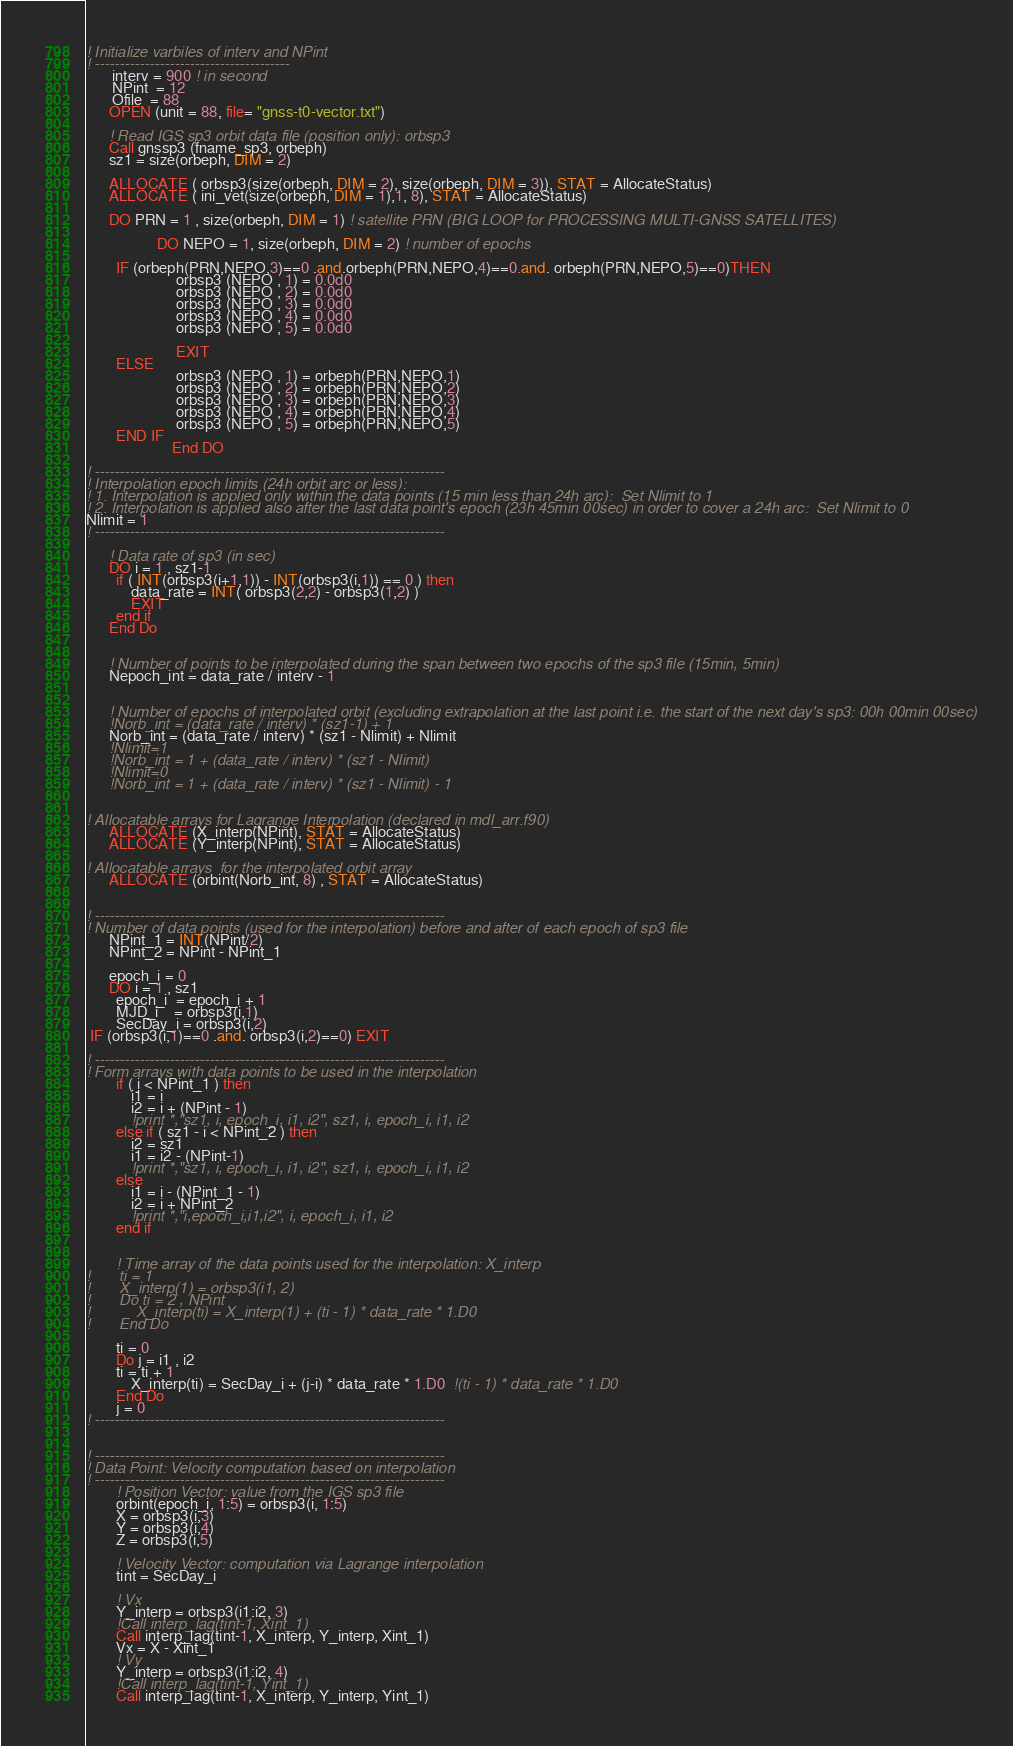Convert code to text. <code><loc_0><loc_0><loc_500><loc_500><_FORTRAN_>! Initialize varbiles of interv and NPint
! ---------------------------------------
       interv = 900 ! in second
       NPint  = 12 
       Ofile  = 88
      OPEN (unit = 88, file= "gnss-t0-vector.txt")

	  ! Read IGS sp3 orbit data file (position only): orbsp3 
      Call gnssp3 (fname_sp3, orbeph)
	  sz1 = size(orbeph, DIM = 2)

      ALLOCATE ( orbsp3(size(orbeph, DIM = 2), size(orbeph, DIM = 3)), STAT = AllocateStatus)
      ALLOCATE ( ini_vet(size(orbeph, DIM = 1),1, 8), STAT = AllocateStatus)

      DO PRN = 1 , size(orbeph, DIM = 1) ! satellite PRN (BIG LOOP for PROCESSING MULTI-GNSS SATELLITES)

	               DO NEPO = 1, size(orbeph, DIM = 2) ! number of epochs

        IF (orbeph(PRN,NEPO,3)==0 .and.orbeph(PRN,NEPO,4)==0.and. orbeph(PRN,NEPO,5)==0)THEN
                        orbsp3 (NEPO , 1) = 0.0d0
                        orbsp3 (NEPO , 2) = 0.0d0
                        orbsp3 (NEPO , 3) = 0.0d0
                        orbsp3 (NEPO , 4) = 0.0d0
                        orbsp3 (NEPO , 5) = 0.0d0

                        EXIT 
        ELSE
                        orbsp3 (NEPO , 1) = orbeph(PRN,NEPO,1)
                        orbsp3 (NEPO , 2) = orbeph(PRN,NEPO,2)
                        orbsp3 (NEPO , 3) = orbeph(PRN,NEPO,3)
                        orbsp3 (NEPO , 4) = orbeph(PRN,NEPO,4)
                        orbsp3 (NEPO , 5) = orbeph(PRN,NEPO,5)
        END IF
                       End DO
 
! ----------------------------------------------------------------------
! Interpolation epoch limits (24h orbit arc or less):
! 1. Interpolation is applied only within the data points (15 min less than 24h arc):  Set Nlimit to 1
! 2. Interpolation is applied also after the last data point's epoch (23h 45min 00sec) in order to cover a 24h arc:  Set Nlimit to 0
Nlimit = 1
! ----------------------------------------------------------------------
	  
	  ! Data rate of sp3 (in sec)
      DO i = 1 , sz1-1
		if ( INT(orbsp3(i+1,1)) - INT(orbsp3(i,1)) == 0 ) then
			data_rate = INT( orbsp3(2,2) - orbsp3(1,2) )
			EXIT
		end if
	  End Do
	  
	  
      ! Number of points to be interpolated during the span between two epochs of the sp3 file (15min, 5min)
	  Nepoch_int = data_rate / interv - 1
	  
	  
      ! Number of epochs of interpolated orbit (excluding extrapolation at the last point i.e. the start of the next day's sp3: 00h 00min 00sec)
      !Norb_int = (data_rate / interv) * (sz1-1) + 1 
      Norb_int = (data_rate / interv) * (sz1 - Nlimit) + Nlimit
	  !Nlimit=1
      !Norb_int = 1 + (data_rate / interv) * (sz1 - Nlimit)
	  !Nlimit=0	  
      !Norb_int = 1 + (data_rate / interv) * (sz1 - Nlimit) - 1
	  
	  
! Allocatable arrays for Lagrange Interpolation (declared in mdl_arr.f90)
      ALLOCATE (X_interp(NPint), STAT = AllocateStatus)
      ALLOCATE (Y_interp(NPint), STAT = AllocateStatus)

! Allocatable arrays  for the interpolated orbit array
      ALLOCATE (orbint(Norb_int, 8) , STAT = AllocateStatus)
	  
	  
! ----------------------------------------------------------------------
! Number of data points (used for the interpolation) before and after of each epoch of sp3 file	  
      NPint_1 = INT(NPint/2) 
      NPint_2 = NPint - NPint_1 
	  
	  epoch_i = 0
      DO i = 1 , sz1
		epoch_i  = epoch_i + 1
		MJD_i    = orbsp3(i,1)
		SecDay_i = orbsp3(i,2)
 IF (orbsp3(i,1)==0 .and. orbsp3(i,2)==0) EXIT
		
! ----------------------------------------------------------------------
! Form arrays with data points to be used in the interpolation		
		if ( i < NPint_1 ) then
			i1 = i
			i2 = i + (NPint - 1)
			!print *,"sz1, i, epoch_i, i1, i2", sz1, i, epoch_i, i1, i2
		else if ( sz1 - i < NPint_2 ) then
			i2 = sz1
			i1 = i2 - (NPint-1)
			!print *,"sz1, i, epoch_i, i1, i2", sz1, i, epoch_i, i1, i2
		else 
			i1 = i - (NPint_1 - 1)
			i2 = i + NPint_2
			!print *,"i,epoch_i,i1,i2", i, epoch_i, i1, i2
		end if

		
        ! Time array of the data points used for the interpolation: X_interp
!		ti = 1
!		X_interp(1) = orbsp3(i1, 2)
!		Do ti = 2 , NPint 
!			X_interp(ti) = X_interp(1) + (ti - 1) * data_rate * 1.D0			
!		End Do

		ti = 0		
		Do j = i1 , i2
		ti = ti + 1		
			X_interp(ti) = SecDay_i + (j-i) * data_rate * 1.D0  !(ti - 1) * data_rate * 1.D0			
		End Do
	    j = 0		
! ----------------------------------------------------------------------


! ----------------------------------------------------------------------
! Data Point: Velocity computation based on interpolation
! ----------------------------------------------------------------------
		! Position Vector: value from the IGS sp3 file
		orbint(epoch_i, 1:5) = orbsp3(i, 1:5)   							
        X = orbsp3(i,3)
		Y = orbsp3(i,4)
		Z = orbsp3(i,5)
		
		! Velocity Vector: computation via Lagrange interpolation
		tint = SecDay_i
		
		! Vx
		Y_interp = orbsp3(i1:i2, 3)		
		!Call interp_lag(tint-1, Xint_1) 
		Call interp_lag(tint-1, X_interp, Y_interp, Xint_1) 
        Vx = X - Xint_1 
		! Vy
		Y_interp = orbsp3(i1:i2, 4)
		!Call interp_lag(tint-1, Yint_1) 
		Call interp_lag(tint-1, X_interp, Y_interp, Yint_1) </code> 